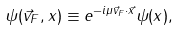Convert formula to latex. <formula><loc_0><loc_0><loc_500><loc_500>\psi ( \vec { v } _ { F } , x ) \equiv e ^ { - i \mu \vec { v } _ { F } \cdot \vec { x } } \psi ( x ) ,</formula> 